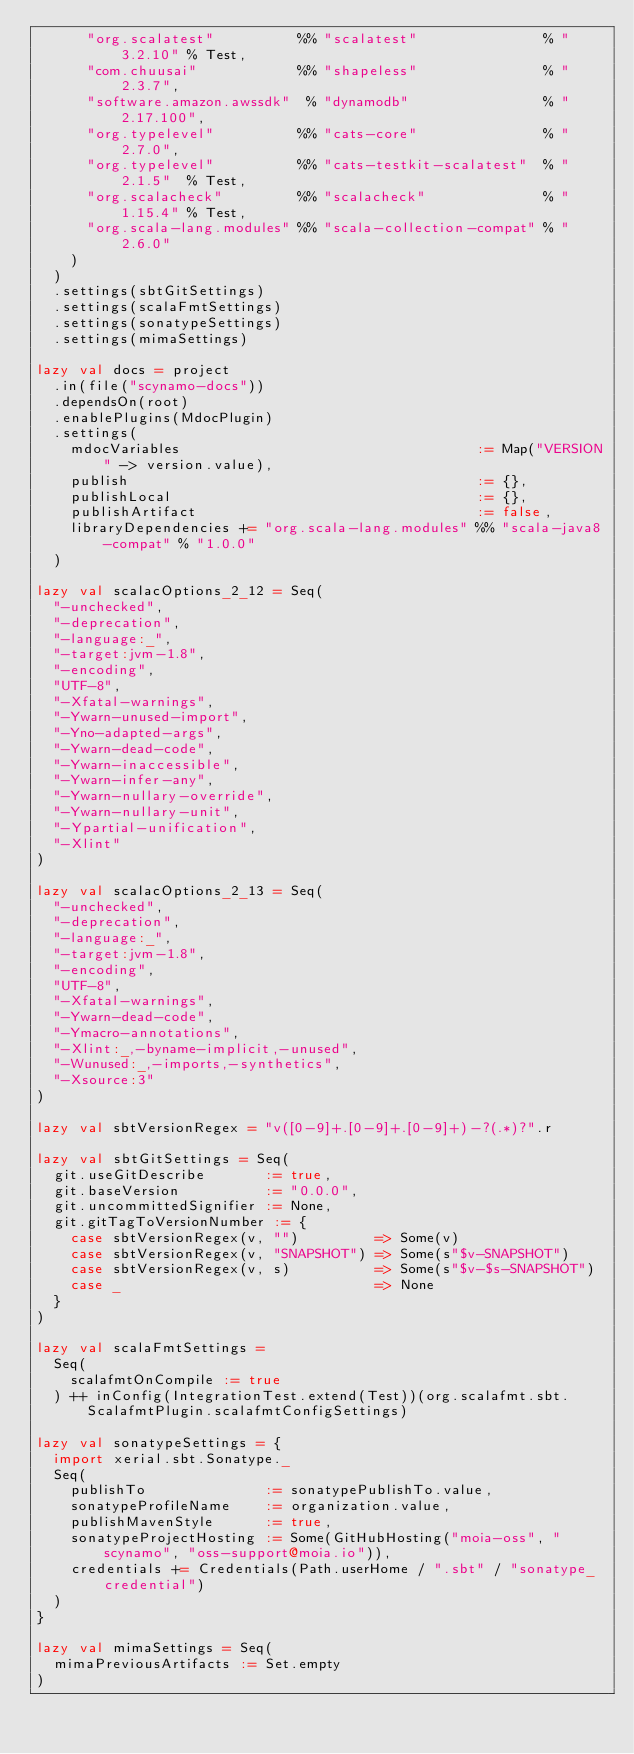Convert code to text. <code><loc_0><loc_0><loc_500><loc_500><_Scala_>      "org.scalatest"          %% "scalatest"               % "3.2.10" % Test,
      "com.chuusai"            %% "shapeless"               % "2.3.7",
      "software.amazon.awssdk"  % "dynamodb"                % "2.17.100",
      "org.typelevel"          %% "cats-core"               % "2.7.0",
      "org.typelevel"          %% "cats-testkit-scalatest"  % "2.1.5"  % Test,
      "org.scalacheck"         %% "scalacheck"              % "1.15.4" % Test,
      "org.scala-lang.modules" %% "scala-collection-compat" % "2.6.0"
    )
  )
  .settings(sbtGitSettings)
  .settings(scalaFmtSettings)
  .settings(sonatypeSettings)
  .settings(mimaSettings)

lazy val docs = project
  .in(file("scynamo-docs"))
  .dependsOn(root)
  .enablePlugins(MdocPlugin)
  .settings(
    mdocVariables                                   := Map("VERSION" -> version.value),
    publish                                         := {},
    publishLocal                                    := {},
    publishArtifact                                 := false,
    libraryDependencies += "org.scala-lang.modules" %% "scala-java8-compat" % "1.0.0"
  )

lazy val scalacOptions_2_12 = Seq(
  "-unchecked",
  "-deprecation",
  "-language:_",
  "-target:jvm-1.8",
  "-encoding",
  "UTF-8",
  "-Xfatal-warnings",
  "-Ywarn-unused-import",
  "-Yno-adapted-args",
  "-Ywarn-dead-code",
  "-Ywarn-inaccessible",
  "-Ywarn-infer-any",
  "-Ywarn-nullary-override",
  "-Ywarn-nullary-unit",
  "-Ypartial-unification",
  "-Xlint"
)

lazy val scalacOptions_2_13 = Seq(
  "-unchecked",
  "-deprecation",
  "-language:_",
  "-target:jvm-1.8",
  "-encoding",
  "UTF-8",
  "-Xfatal-warnings",
  "-Ywarn-dead-code",
  "-Ymacro-annotations",
  "-Xlint:_,-byname-implicit,-unused",
  "-Wunused:_,-imports,-synthetics",
  "-Xsource:3"
)

lazy val sbtVersionRegex = "v([0-9]+.[0-9]+.[0-9]+)-?(.*)?".r

lazy val sbtGitSettings = Seq(
  git.useGitDescribe       := true,
  git.baseVersion          := "0.0.0",
  git.uncommittedSignifier := None,
  git.gitTagToVersionNumber := {
    case sbtVersionRegex(v, "")         => Some(v)
    case sbtVersionRegex(v, "SNAPSHOT") => Some(s"$v-SNAPSHOT")
    case sbtVersionRegex(v, s)          => Some(s"$v-$s-SNAPSHOT")
    case _                              => None
  }
)

lazy val scalaFmtSettings =
  Seq(
    scalafmtOnCompile := true
  ) ++ inConfig(IntegrationTest.extend(Test))(org.scalafmt.sbt.ScalafmtPlugin.scalafmtConfigSettings)

lazy val sonatypeSettings = {
  import xerial.sbt.Sonatype._
  Seq(
    publishTo              := sonatypePublishTo.value,
    sonatypeProfileName    := organization.value,
    publishMavenStyle      := true,
    sonatypeProjectHosting := Some(GitHubHosting("moia-oss", "scynamo", "oss-support@moia.io")),
    credentials += Credentials(Path.userHome / ".sbt" / "sonatype_credential")
  )
}

lazy val mimaSettings = Seq(
  mimaPreviousArtifacts := Set.empty
)
</code> 